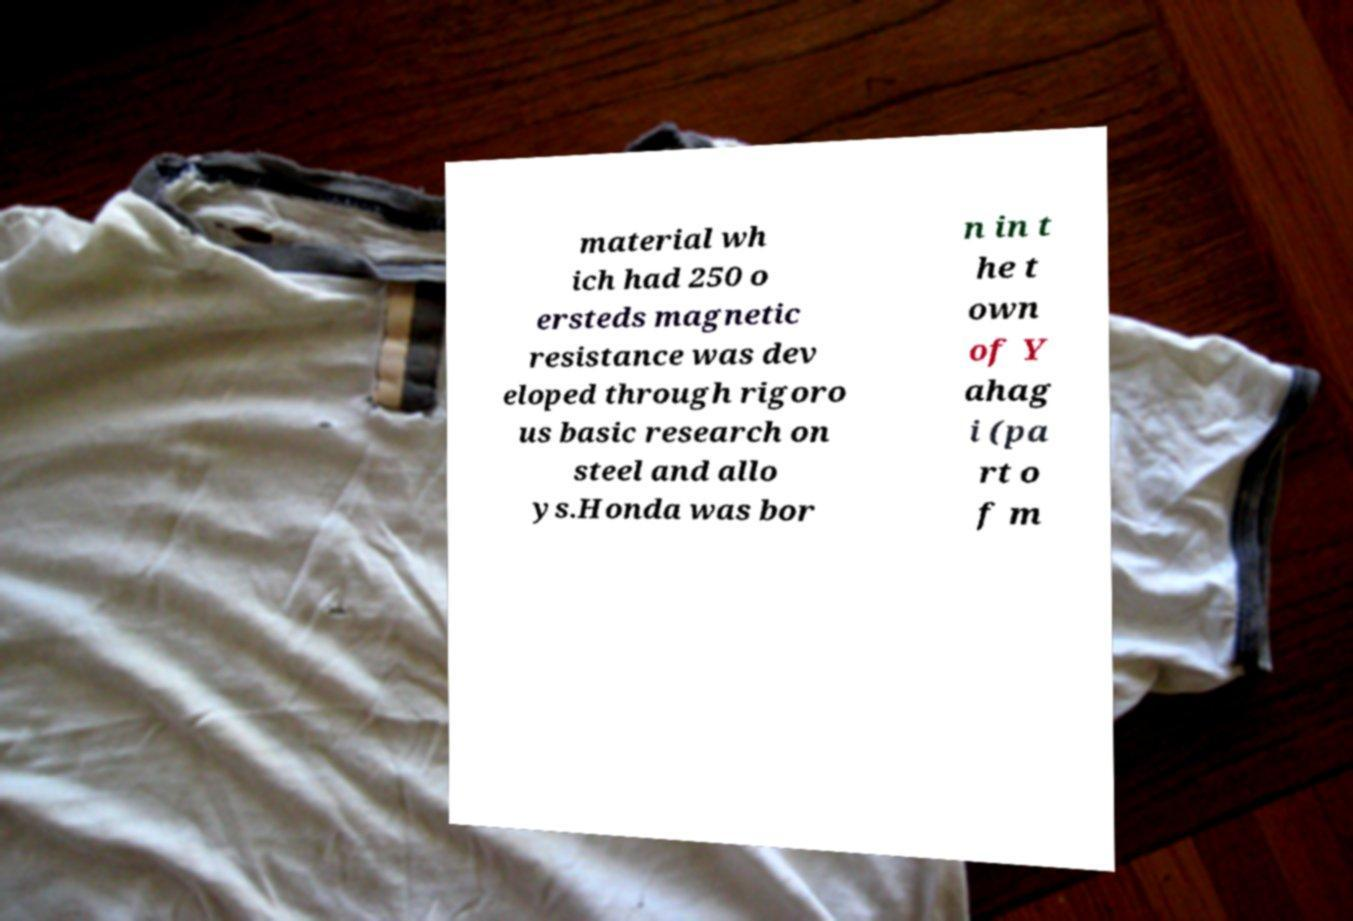There's text embedded in this image that I need extracted. Can you transcribe it verbatim? material wh ich had 250 o ersteds magnetic resistance was dev eloped through rigoro us basic research on steel and allo ys.Honda was bor n in t he t own of Y ahag i (pa rt o f m 